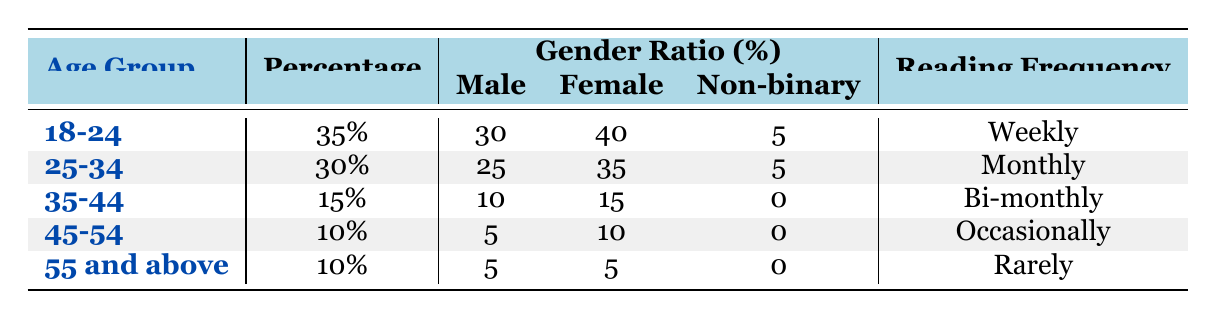What percentage of modernist literature readers are aged 18-24? The table shows that the age group 18-24 has a percentage of 35%.
Answer: 35% Which age group has the highest percentage of readers? Looking at the percentages in the table, the age group 18-24 has the highest percentage at 35%.
Answer: 18-24 What is the reading frequency of the 35-44 age group? The table states that the reading frequency for the 35-44 age group is bi-monthly.
Answer: Bi-monthly How many percent of readers from the age group 45-54 are male? According to the table, the percentage of male readers in the 45-54 age group is 5%.
Answer: 5% What is the combined percentage of readers from the age groups 45-54 and 55 and above? The percentage for 45-54 is 10% and for 55 and above is also 10%. Adding these gives 10 + 10 = 20%.
Answer: 20% Do more females than males read modernist literature in the 18-24 age group? The gender ratio for the 18-24 age group is 40% female and 30% male, meaning there are more females than males.
Answer: Yes What is the reading frequency for the 25-34 age group and does it differ from the 18-24 age group? The reading frequency for the 25-34 age group is monthly while for the 18-24 age group it is weekly. Therefore, there is a difference in frequency.
Answer: Yes Which age group displays a non-binary percentage of 5%? The table indicates that both the 18-24 and 25-34 age groups have a non-binary percentage of 5%.
Answer: 18-24 and 25-34 Calculate the average percentage of readers between the age groups 35-44 and 45-54. The percentages for 35-44 and 45-54 are 15% and 10%, respectively. The average is (15 + 10)/2 = 12.5%.
Answer: 12.5% 